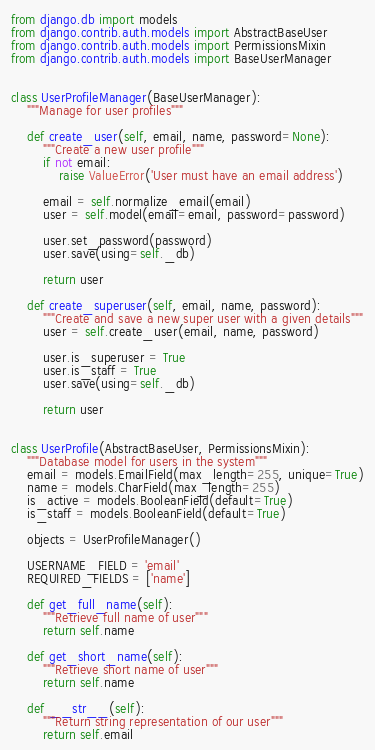<code> <loc_0><loc_0><loc_500><loc_500><_Python_>from django.db import models
from django.contrib.auth.models import AbstractBaseUser
from django.contrib.auth.models import PermissionsMixin
from django.contrib.auth.models import BaseUserManager


class UserProfileManager(BaseUserManager):
    """Manage for user profiles"""

    def create_user(self, email, name, password=None):
        """Create a new user profile"""
        if not email:
            raise ValueError('User must have an email address')

        email = self.normalize_email(email)
        user = self.model(email=email, password=password)

        user.set_password(password)
        user.save(using=self._db)

        return user

    def create_superuser(self, email, name, password):
        """Create and save a new super user with a given details"""
        user = self.create_user(email, name, password)

        user.is_superuser = True 
        user.is_staff = True 
        user.save(using=self._db)

        return user


class UserProfile(AbstractBaseUser, PermissionsMixin):
    """Database model for users in the system"""
    email = models.EmailField(max_length=255, unique=True)
    name = models.CharField(max_length=255)
    is_active = models.BooleanField(default=True)
    is_staff = models.BooleanField(default=True)

    objects = UserProfileManager()

    USERNAME_FIELD = 'email'
    REQUIRED_FIELDS = ['name']
    
    def get_full_name(self):
        """Retrieve full name of user"""
        return self.name

    def get_short_name(self):
        """Retrieve short name of user"""
        return self.name

    def __str__(self):
        """Return string representation of our user"""
        return self.email
</code> 